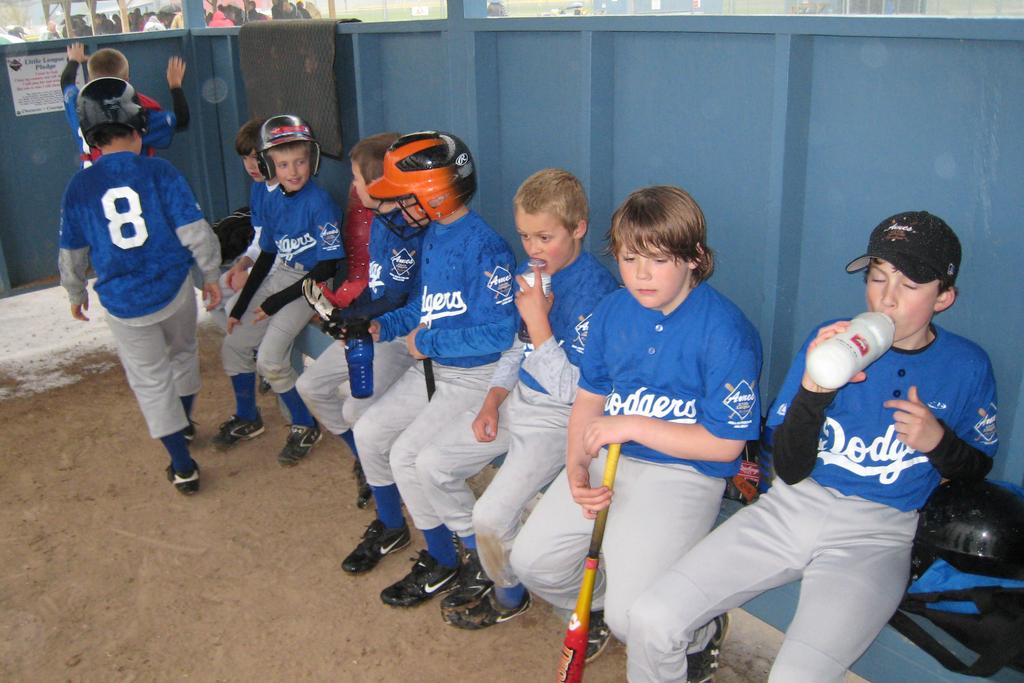What team do they play for?
Make the answer very short. Dodgers. What number is on the player's back?
Your response must be concise. 8. 